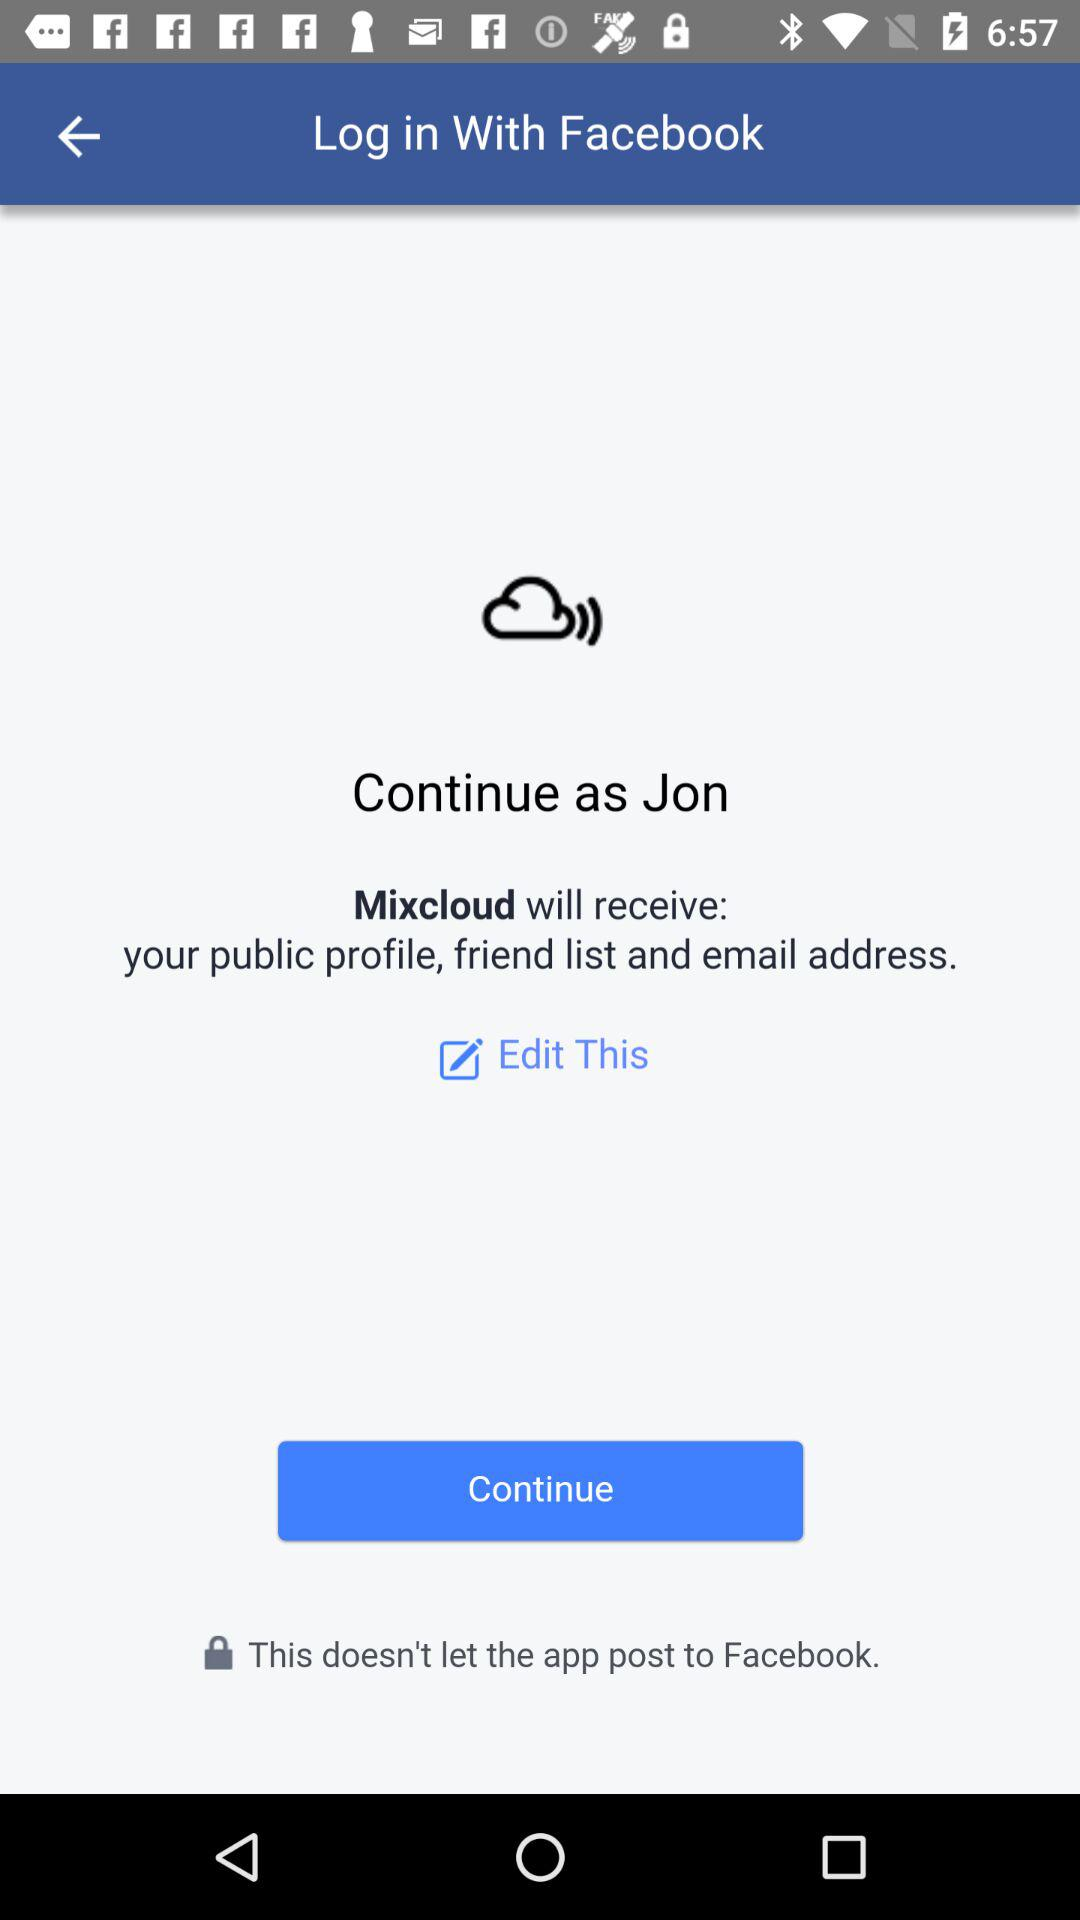What is the name of the user? The name of the user is Jon. 